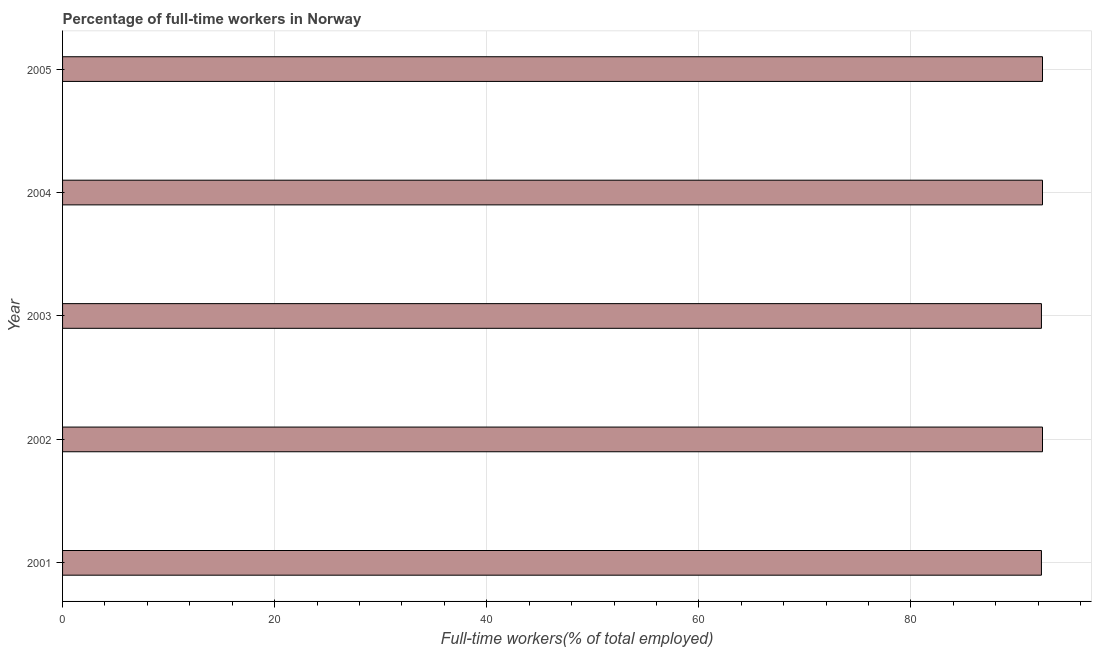Does the graph contain any zero values?
Your response must be concise. No. What is the title of the graph?
Keep it short and to the point. Percentage of full-time workers in Norway. What is the label or title of the X-axis?
Give a very brief answer. Full-time workers(% of total employed). What is the percentage of full-time workers in 2003?
Provide a succinct answer. 92.3. Across all years, what is the maximum percentage of full-time workers?
Your answer should be very brief. 92.4. Across all years, what is the minimum percentage of full-time workers?
Keep it short and to the point. 92.3. In which year was the percentage of full-time workers maximum?
Give a very brief answer. 2002. In which year was the percentage of full-time workers minimum?
Your answer should be compact. 2001. What is the sum of the percentage of full-time workers?
Ensure brevity in your answer.  461.8. What is the average percentage of full-time workers per year?
Your response must be concise. 92.36. What is the median percentage of full-time workers?
Your answer should be very brief. 92.4. Do a majority of the years between 2002 and 2003 (inclusive) have percentage of full-time workers greater than 80 %?
Offer a very short reply. Yes. Is the difference between the percentage of full-time workers in 2004 and 2005 greater than the difference between any two years?
Your answer should be compact. No. In how many years, is the percentage of full-time workers greater than the average percentage of full-time workers taken over all years?
Provide a succinct answer. 3. What is the Full-time workers(% of total employed) of 2001?
Offer a very short reply. 92.3. What is the Full-time workers(% of total employed) in 2002?
Ensure brevity in your answer.  92.4. What is the Full-time workers(% of total employed) in 2003?
Ensure brevity in your answer.  92.3. What is the Full-time workers(% of total employed) in 2004?
Keep it short and to the point. 92.4. What is the Full-time workers(% of total employed) of 2005?
Provide a short and direct response. 92.4. What is the difference between the Full-time workers(% of total employed) in 2002 and 2003?
Your response must be concise. 0.1. What is the difference between the Full-time workers(% of total employed) in 2002 and 2004?
Make the answer very short. 0. What is the difference between the Full-time workers(% of total employed) in 2004 and 2005?
Make the answer very short. 0. What is the ratio of the Full-time workers(% of total employed) in 2001 to that in 2003?
Keep it short and to the point. 1. What is the ratio of the Full-time workers(% of total employed) in 2001 to that in 2004?
Your answer should be compact. 1. What is the ratio of the Full-time workers(% of total employed) in 2002 to that in 2003?
Your answer should be compact. 1. What is the ratio of the Full-time workers(% of total employed) in 2002 to that in 2004?
Ensure brevity in your answer.  1. What is the ratio of the Full-time workers(% of total employed) in 2002 to that in 2005?
Ensure brevity in your answer.  1. 